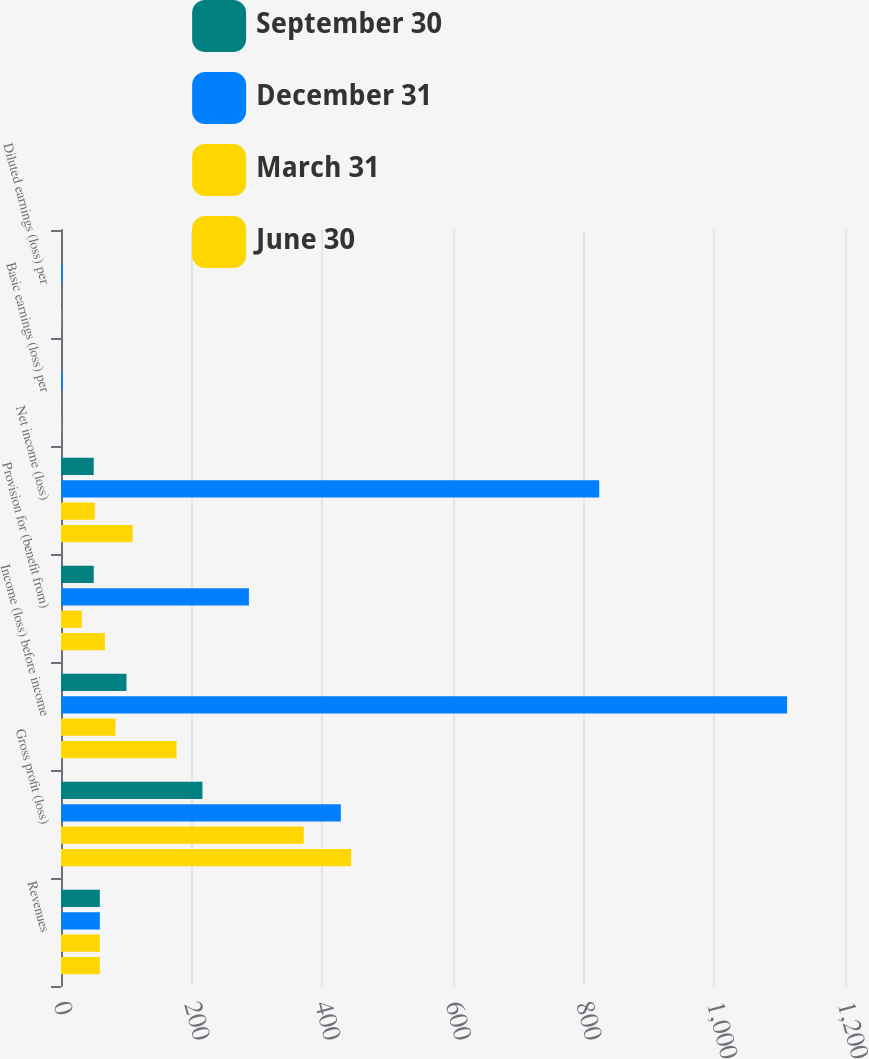<chart> <loc_0><loc_0><loc_500><loc_500><stacked_bar_chart><ecel><fcel>Revenues<fcel>Gross profit (loss)<fcel>Income (loss) before income<fcel>Provision for (benefit from)<fcel>Net income (loss)<fcel>Basic earnings (loss) per<fcel>Diluted earnings (loss) per<nl><fcel>September 30<fcel>59.45<fcel>216.5<fcel>100.2<fcel>50.1<fcel>50.1<fcel>0.16<fcel>0.16<nl><fcel>December 31<fcel>59.45<fcel>428.3<fcel>1111.4<fcel>287.6<fcel>823.8<fcel>2.62<fcel>2.62<nl><fcel>March 31<fcel>59.45<fcel>371.5<fcel>83.4<fcel>31.7<fcel>51.7<fcel>0.16<fcel>0.16<nl><fcel>June 30<fcel>59.45<fcel>444<fcel>176.9<fcel>67.2<fcel>109.7<fcel>0.35<fcel>0.35<nl></chart> 